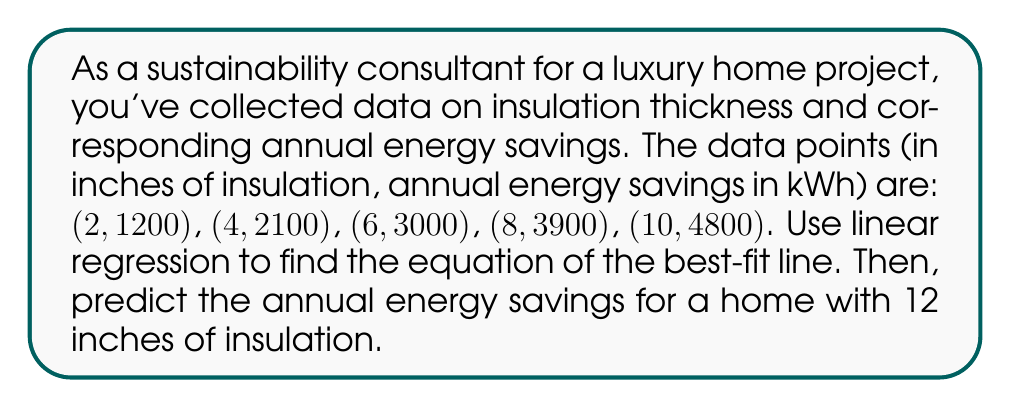Provide a solution to this math problem. To solve this problem, we'll use linear regression to find the equation of the best-fit line in the form $y = mx + b$, where $m$ is the slope and $b$ is the y-intercept.

1. Calculate the means of x and y:
   $\bar{x} = \frac{2 + 4 + 6 + 8 + 10}{5} = 6$
   $\bar{y} = \frac{1200 + 2100 + 3000 + 3900 + 4800}{5} = 3000$

2. Calculate the slope $m$ using the formula:
   $$m = \frac{\sum(x_i - \bar{x})(y_i - \bar{y})}{\sum(x_i - \bar{x})^2}$$

   $\sum(x_i - \bar{x})(y_i - \bar{y}) = (-4)(-1800) + (-2)(-900) + 0(0) + 2(900) + 4(1800) = 14400$
   $\sum(x_i - \bar{x})^2 = (-4)^2 + (-2)^2 + 0^2 + 2^2 + 4^2 = 40$

   $m = \frac{14400}{40} = 360$

3. Calculate the y-intercept $b$ using the formula:
   $b = \bar{y} - m\bar{x} = 3000 - 360(6) = 840$

4. The equation of the best-fit line is:
   $y = 360x + 840$

5. To predict the annual energy savings for 12 inches of insulation, substitute $x = 12$ into the equation:
   $y = 360(12) + 840 = 5160$

Therefore, the predicted annual energy savings for a home with 12 inches of insulation is 5160 kWh.
Answer: The equation of the best-fit line is $y = 360x + 840$, where $x$ is the insulation thickness in inches and $y$ is the annual energy savings in kWh. The predicted annual energy savings for a home with 12 inches of insulation is 5160 kWh. 